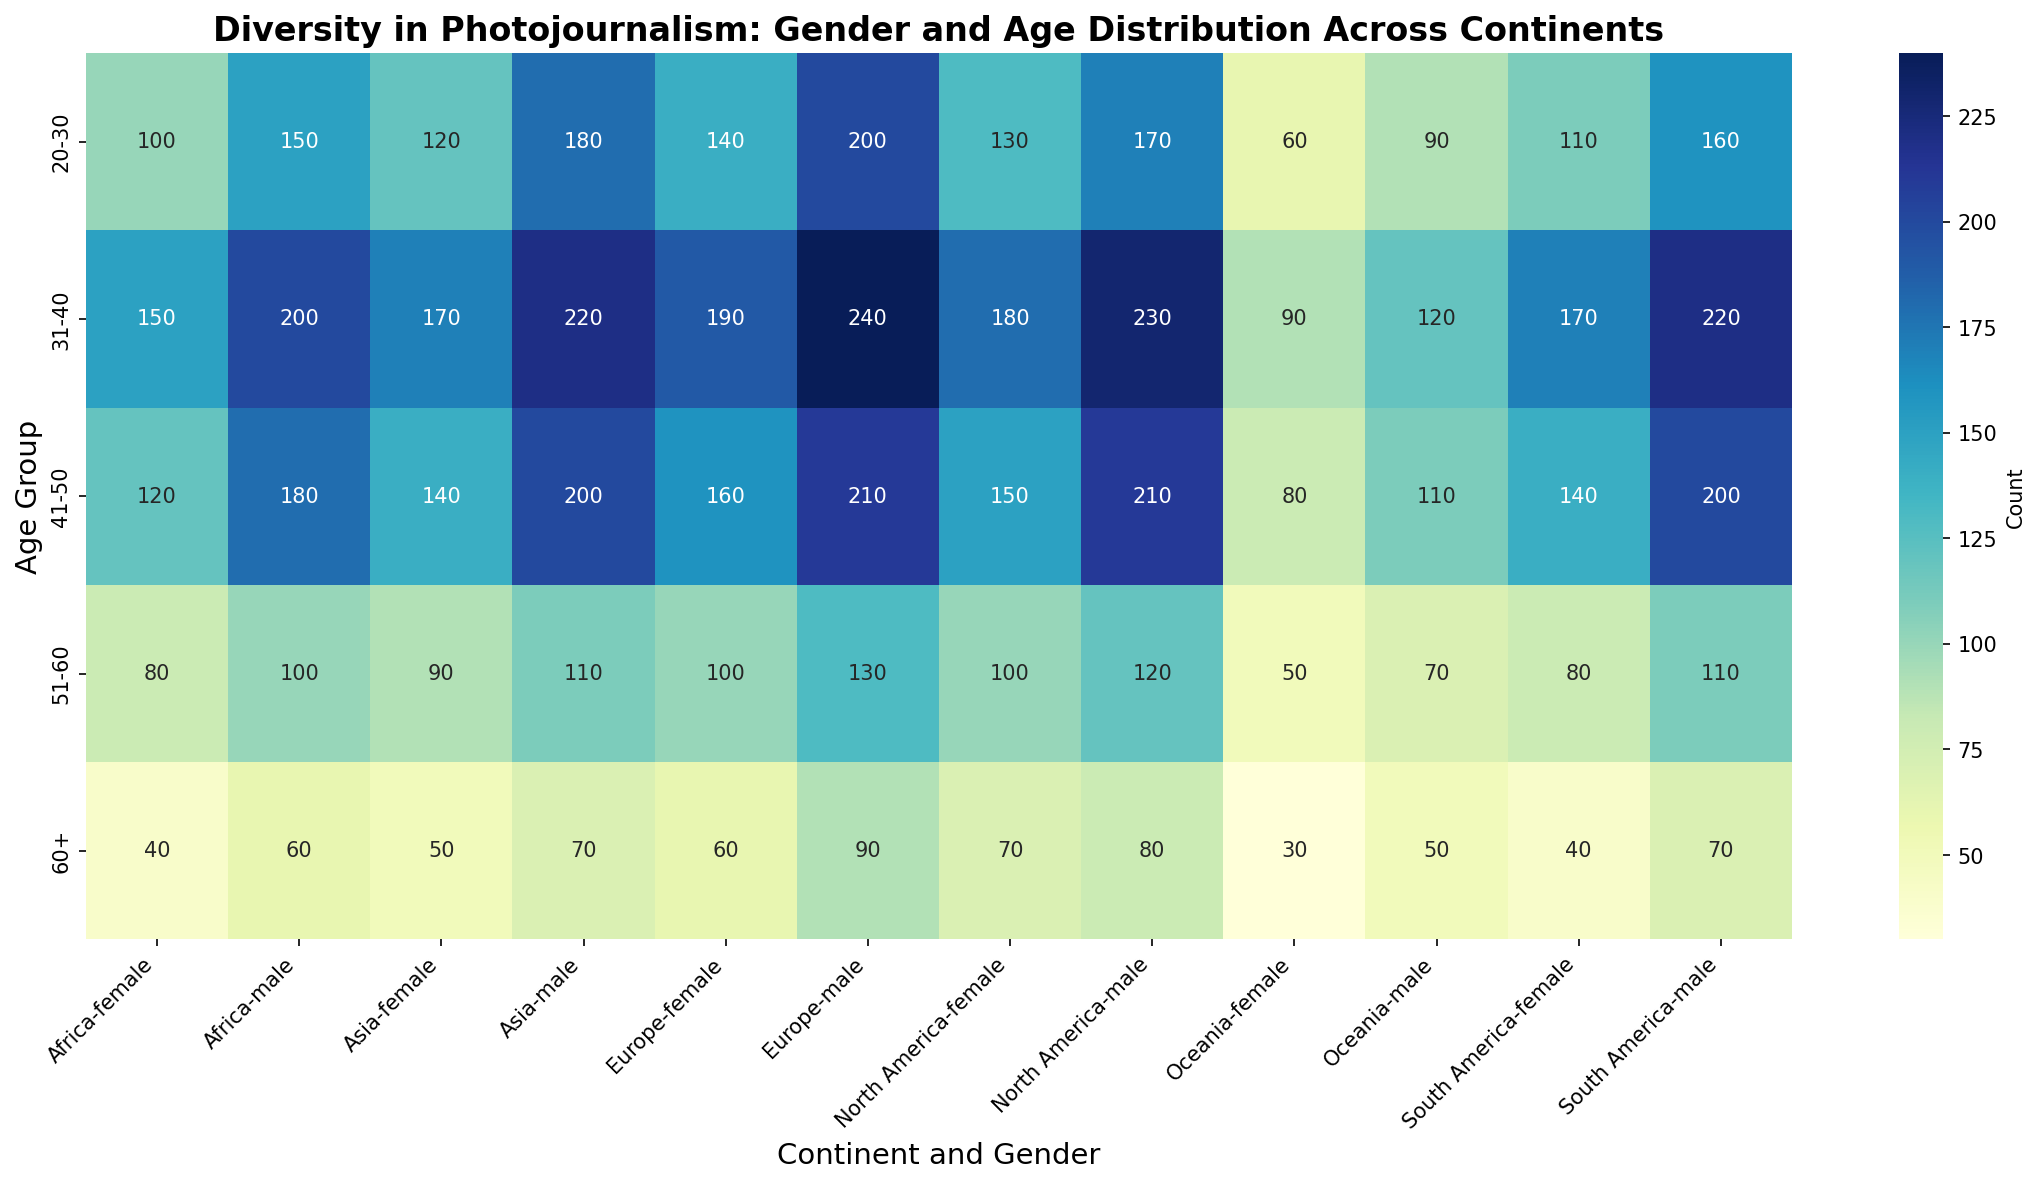What is the total count of male photojournalists aged 31-40 across all continents? First, identify the counts of male photojournalists aged 31-40 from each continent: Africa (200), Asia (220), Europe (240), North America (230), South America (220), and Oceania (120). Then sum these values: 200 + 220 + 240 + 230 + 220 + 120 = 1230.
Answer: 1230 Which continent has the highest number of female photojournalists in the 20-30 age group? Check the counts for female photojournalists aged 20-30 from each continent: Africa (100), Asia (120), Europe (140), North America (130), South America (110), and Oceania (60). Europe has the highest count of 140.
Answer: Europe What is the difference in the count of male and female photojournalists for the age group 51-60 in South America? Identify the counts for male (110) and female (80) photojournalists aged 51-60 in South America. Calculate the difference: 110 - 80 = 30.
Answer: 30 Which age group has the least number of female photojournalists in Oceania? Look at the counts for female photojournalists across all age groups in Oceania: 20-30 (60), 31-40 (90), 41-50 (80), 51-60 (50), 60+ (30). The age group 60+ has the least number with 30.
Answer: 60+ Does North America have more male or female photojournalists in the 60+ age group? Compare the counts for male (80) and female (70) photojournalists aged 60+ in North America. There are more male photojournalists (80).
Answer: Male What is the average count of female photojournalists aged 41-50 across all continents? Sum the counts of female photojournalists aged 41-50 for each continent: Africa (120), Asia (140), Europe (160), North America (150), South America (140), Oceania (80). Then divide by the number of continents: (120 + 140 + 160 + 150 + 140 + 80) / 6 = 790 / 6 ≈ 131.67.
Answer: 131.67 How does the count of male photojournalists aged 20-30 in Europe compare to that in Asia? Identify the counts for male photojournalists aged 20-30 in Europe (200) and Asia (180). The count in Europe (200) is greater than in Asia (180).
Answer: Europe has more Which gender in Africa has a higher count of photojournalists in the age group 41-50? Compare the counts for male (180) and female (120) photojournalists aged 41-50 in Africa. Males have a higher count (180).
Answer: Male What is the sum of male and female photojournalists aged 51-60 in North America? Identify the counts for male (120) and female (100) photojournalists aged 51-60 in North America. Add these values: 120 + 100 = 220.
Answer: 220 In which continent do female photojournalists aged 31-40 form the largest group? Compare the counts of female photojournalists aged 31-40 across all continents: Africa (150), Asia (170), Europe (190), North America (180), South America (170), Oceania (90). Europe has the largest count with 190.
Answer: Europe 